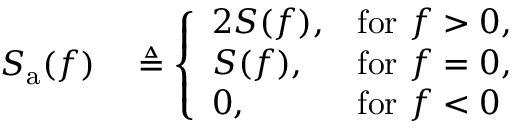<formula> <loc_0><loc_0><loc_500><loc_500>\begin{array} { r l } { S _ { a } ( f ) } & \triangle q { \left \{ \begin{array} { l l } { 2 S ( f ) , } & { { f o r } \ f > 0 , } \\ { S ( f ) , } & { { f o r } \ f = 0 , } \\ { 0 , } & { { f o r } \ f < 0 } \end{array} } } \end{array}</formula> 